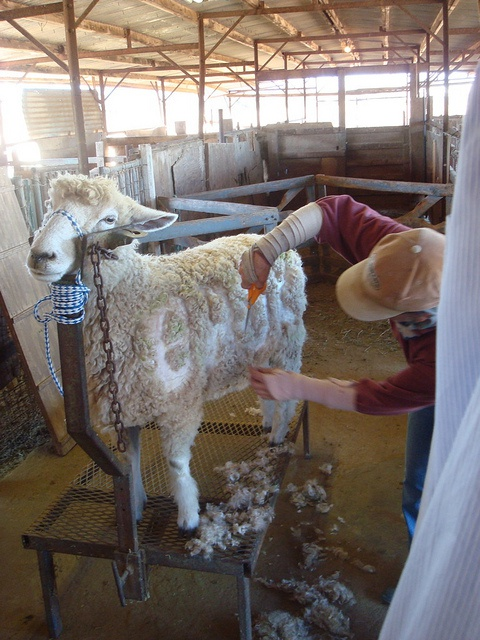Describe the objects in this image and their specific colors. I can see sheep in brown, darkgray, gray, and lightgray tones, people in brown, black, gray, and maroon tones, and scissors in brown, gray, and maroon tones in this image. 